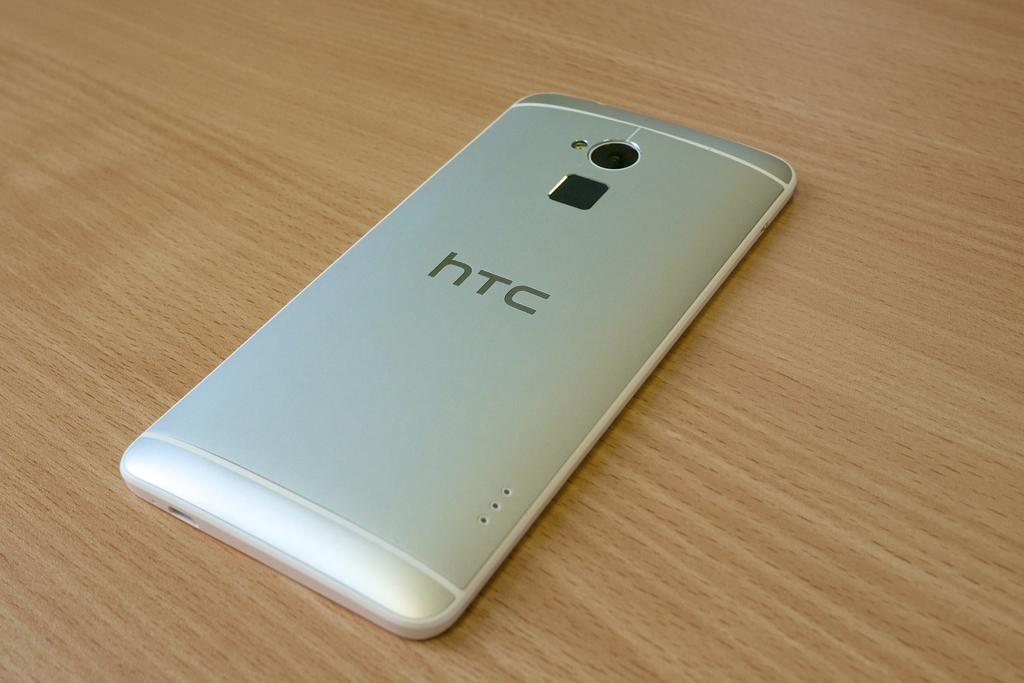<image>
Relay a brief, clear account of the picture shown. A silver colored smartphone with the letters htc on the back 